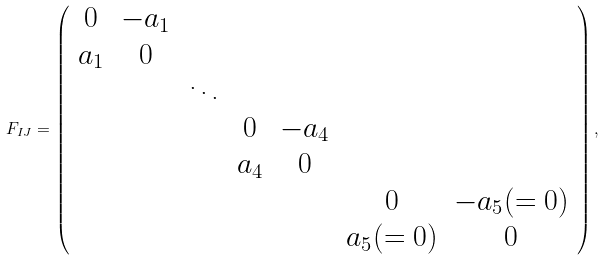<formula> <loc_0><loc_0><loc_500><loc_500>F _ { I J } = \left ( \begin{array} { c c c c c c c } 0 & - a _ { 1 } & & & & & \\ a _ { 1 } & 0 & & & & & \\ & & \ddots & & & & \\ & & & 0 & - a _ { 4 } & & \\ & & & a _ { 4 } & 0 & & \\ & & & & & 0 & - a _ { 5 } ( = 0 ) \\ & & & & & a _ { 5 } ( = 0 ) & 0 \\ \end{array} \right ) ,</formula> 